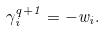<formula> <loc_0><loc_0><loc_500><loc_500>\gamma _ { i } ^ { q + 1 } = - w _ { i } .</formula> 